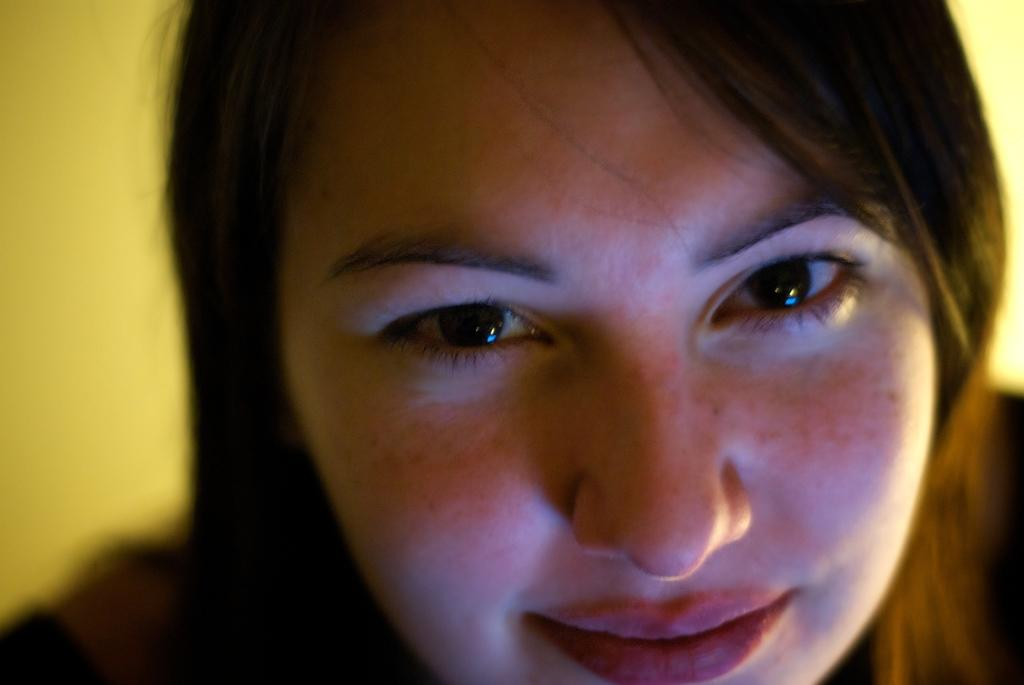Who is present in the image? There is a woman in the image. What can be seen in the background of the image? The background of the image is yellow. Is there a bridge visible in the image? No, there is no bridge present in the image. What caused the yellow background in the image? The cause of the yellow background is not mentioned in the image or the provided facts. 